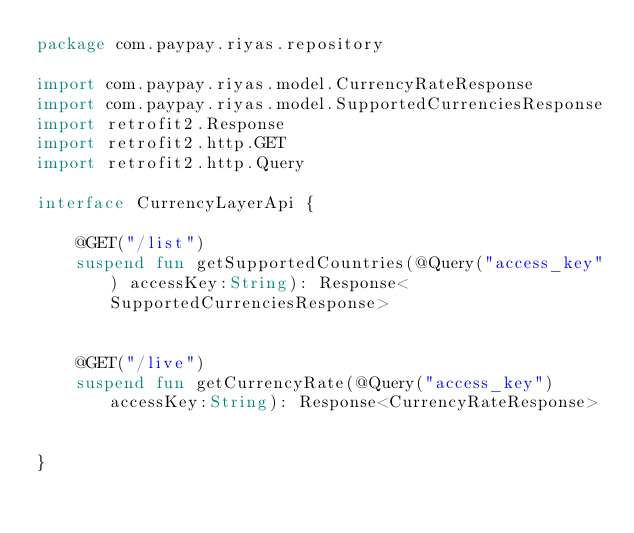<code> <loc_0><loc_0><loc_500><loc_500><_Kotlin_>package com.paypay.riyas.repository

import com.paypay.riyas.model.CurrencyRateResponse
import com.paypay.riyas.model.SupportedCurrenciesResponse
import retrofit2.Response
import retrofit2.http.GET
import retrofit2.http.Query

interface CurrencyLayerApi {

    @GET("/list")
    suspend fun getSupportedCountries(@Query("access_key") accessKey:String): Response<SupportedCurrenciesResponse>


    @GET("/live")
    suspend fun getCurrencyRate(@Query("access_key") accessKey:String): Response<CurrencyRateResponse>


}</code> 